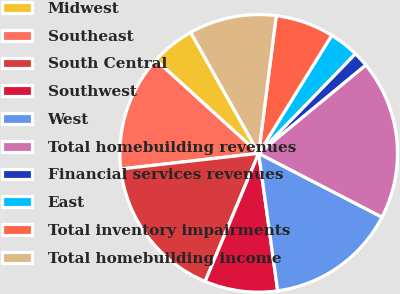<chart> <loc_0><loc_0><loc_500><loc_500><pie_chart><fcel>Midwest<fcel>Southeast<fcel>South Central<fcel>Southwest<fcel>West<fcel>Total homebuilding revenues<fcel>Financial services revenues<fcel>East<fcel>Total inventory impairments<fcel>Total homebuilding income<nl><fcel>5.12%<fcel>13.53%<fcel>16.9%<fcel>8.49%<fcel>15.22%<fcel>18.58%<fcel>1.76%<fcel>3.44%<fcel>6.8%<fcel>10.17%<nl></chart> 